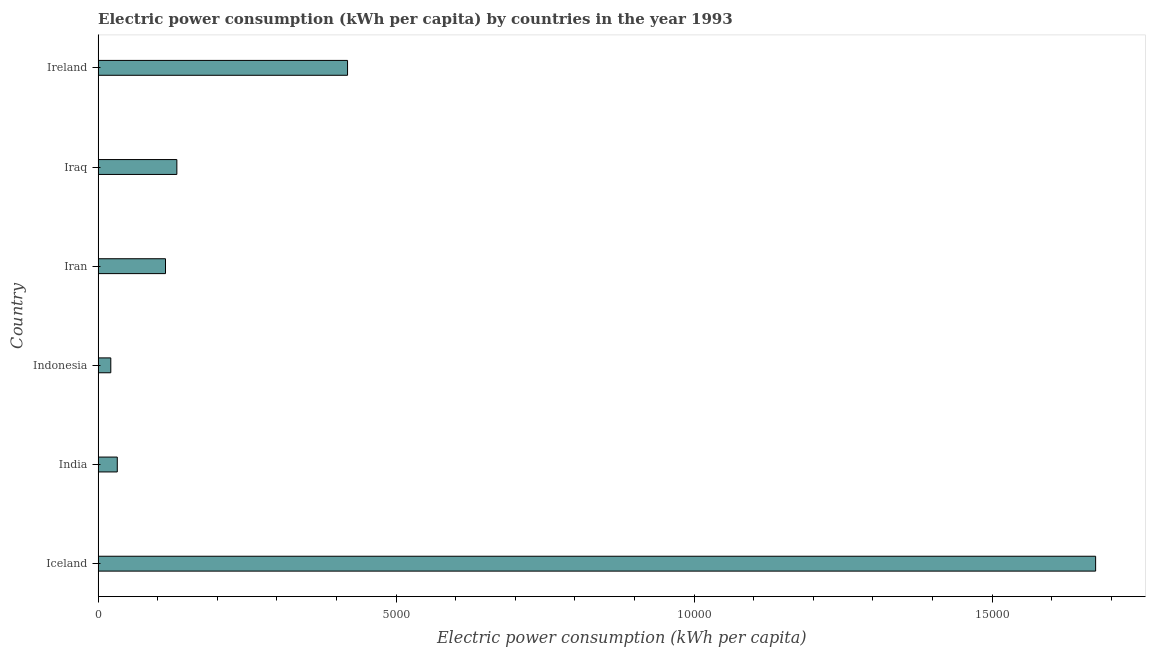Does the graph contain any zero values?
Keep it short and to the point. No. Does the graph contain grids?
Your answer should be very brief. No. What is the title of the graph?
Keep it short and to the point. Electric power consumption (kWh per capita) by countries in the year 1993. What is the label or title of the X-axis?
Provide a succinct answer. Electric power consumption (kWh per capita). What is the label or title of the Y-axis?
Your answer should be very brief. Country. What is the electric power consumption in Ireland?
Your answer should be compact. 4185.1. Across all countries, what is the maximum electric power consumption?
Offer a terse response. 1.67e+04. Across all countries, what is the minimum electric power consumption?
Ensure brevity in your answer.  212.83. In which country was the electric power consumption minimum?
Make the answer very short. Indonesia. What is the sum of the electric power consumption?
Offer a very short reply. 2.39e+04. What is the difference between the electric power consumption in Iceland and India?
Make the answer very short. 1.64e+04. What is the average electric power consumption per country?
Provide a short and direct response. 3984.76. What is the median electric power consumption?
Your answer should be compact. 1225.98. In how many countries, is the electric power consumption greater than 3000 kWh per capita?
Give a very brief answer. 2. What is the ratio of the electric power consumption in Iceland to that in India?
Make the answer very short. 52.05. Is the electric power consumption in India less than that in Iran?
Keep it short and to the point. Yes. What is the difference between the highest and the second highest electric power consumption?
Provide a succinct answer. 1.26e+04. What is the difference between the highest and the lowest electric power consumption?
Your response must be concise. 1.65e+04. In how many countries, is the electric power consumption greater than the average electric power consumption taken over all countries?
Provide a short and direct response. 2. How many bars are there?
Offer a very short reply. 6. How many countries are there in the graph?
Make the answer very short. 6. What is the difference between two consecutive major ticks on the X-axis?
Make the answer very short. 5000. Are the values on the major ticks of X-axis written in scientific E-notation?
Provide a short and direct response. No. What is the Electric power consumption (kWh per capita) in Iceland?
Offer a terse response. 1.67e+04. What is the Electric power consumption (kWh per capita) in India?
Give a very brief answer. 321.57. What is the Electric power consumption (kWh per capita) in Indonesia?
Your answer should be compact. 212.83. What is the Electric power consumption (kWh per capita) of Iran?
Your response must be concise. 1130.74. What is the Electric power consumption (kWh per capita) in Iraq?
Provide a succinct answer. 1321.21. What is the Electric power consumption (kWh per capita) of Ireland?
Give a very brief answer. 4185.1. What is the difference between the Electric power consumption (kWh per capita) in Iceland and India?
Provide a succinct answer. 1.64e+04. What is the difference between the Electric power consumption (kWh per capita) in Iceland and Indonesia?
Provide a short and direct response. 1.65e+04. What is the difference between the Electric power consumption (kWh per capita) in Iceland and Iran?
Your answer should be compact. 1.56e+04. What is the difference between the Electric power consumption (kWh per capita) in Iceland and Iraq?
Your answer should be compact. 1.54e+04. What is the difference between the Electric power consumption (kWh per capita) in Iceland and Ireland?
Give a very brief answer. 1.26e+04. What is the difference between the Electric power consumption (kWh per capita) in India and Indonesia?
Offer a very short reply. 108.74. What is the difference between the Electric power consumption (kWh per capita) in India and Iran?
Provide a succinct answer. -809.18. What is the difference between the Electric power consumption (kWh per capita) in India and Iraq?
Ensure brevity in your answer.  -999.64. What is the difference between the Electric power consumption (kWh per capita) in India and Ireland?
Keep it short and to the point. -3863.53. What is the difference between the Electric power consumption (kWh per capita) in Indonesia and Iran?
Provide a succinct answer. -917.91. What is the difference between the Electric power consumption (kWh per capita) in Indonesia and Iraq?
Your answer should be compact. -1108.38. What is the difference between the Electric power consumption (kWh per capita) in Indonesia and Ireland?
Your answer should be very brief. -3972.27. What is the difference between the Electric power consumption (kWh per capita) in Iran and Iraq?
Your answer should be very brief. -190.47. What is the difference between the Electric power consumption (kWh per capita) in Iran and Ireland?
Provide a succinct answer. -3054.36. What is the difference between the Electric power consumption (kWh per capita) in Iraq and Ireland?
Your response must be concise. -2863.89. What is the ratio of the Electric power consumption (kWh per capita) in Iceland to that in India?
Your answer should be compact. 52.05. What is the ratio of the Electric power consumption (kWh per capita) in Iceland to that in Indonesia?
Provide a short and direct response. 78.64. What is the ratio of the Electric power consumption (kWh per capita) in Iceland to that in Iran?
Ensure brevity in your answer.  14.8. What is the ratio of the Electric power consumption (kWh per capita) in Iceland to that in Iraq?
Your response must be concise. 12.67. What is the ratio of the Electric power consumption (kWh per capita) in Iceland to that in Ireland?
Make the answer very short. 4. What is the ratio of the Electric power consumption (kWh per capita) in India to that in Indonesia?
Offer a very short reply. 1.51. What is the ratio of the Electric power consumption (kWh per capita) in India to that in Iran?
Make the answer very short. 0.28. What is the ratio of the Electric power consumption (kWh per capita) in India to that in Iraq?
Make the answer very short. 0.24. What is the ratio of the Electric power consumption (kWh per capita) in India to that in Ireland?
Your response must be concise. 0.08. What is the ratio of the Electric power consumption (kWh per capita) in Indonesia to that in Iran?
Keep it short and to the point. 0.19. What is the ratio of the Electric power consumption (kWh per capita) in Indonesia to that in Iraq?
Your answer should be very brief. 0.16. What is the ratio of the Electric power consumption (kWh per capita) in Indonesia to that in Ireland?
Provide a short and direct response. 0.05. What is the ratio of the Electric power consumption (kWh per capita) in Iran to that in Iraq?
Your response must be concise. 0.86. What is the ratio of the Electric power consumption (kWh per capita) in Iran to that in Ireland?
Your response must be concise. 0.27. What is the ratio of the Electric power consumption (kWh per capita) in Iraq to that in Ireland?
Ensure brevity in your answer.  0.32. 